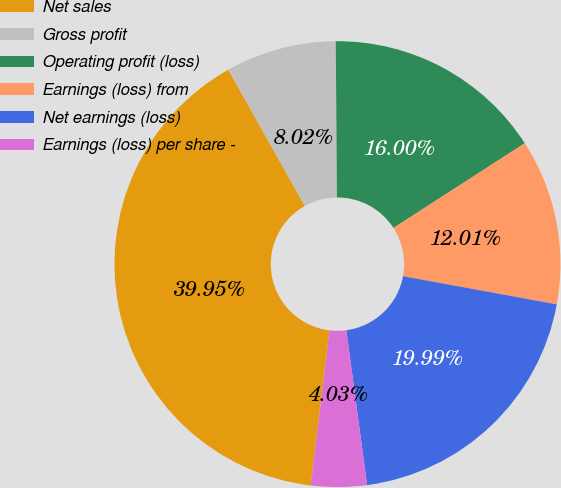Convert chart. <chart><loc_0><loc_0><loc_500><loc_500><pie_chart><fcel>Net sales<fcel>Gross profit<fcel>Operating profit (loss)<fcel>Earnings (loss) from<fcel>Net earnings (loss)<fcel>Earnings (loss) per share -<nl><fcel>39.95%<fcel>8.02%<fcel>16.0%<fcel>12.01%<fcel>19.99%<fcel>4.03%<nl></chart> 